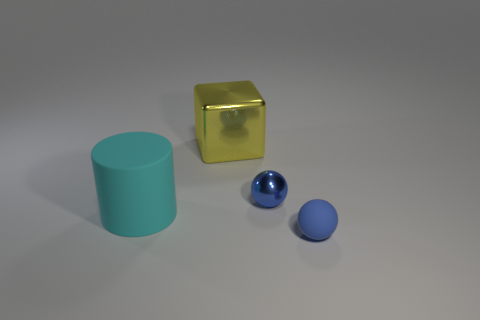What number of things are made of the same material as the big cyan cylinder?
Ensure brevity in your answer.  1. Do the tiny blue ball that is in front of the metallic sphere and the large yellow thing have the same material?
Give a very brief answer. No. Is the number of big rubber objects on the right side of the yellow metal block the same as the number of purple metal balls?
Offer a terse response. Yes. What is the size of the cylinder?
Keep it short and to the point. Large. What material is the object that is the same color as the metal ball?
Make the answer very short. Rubber. How many large metal blocks are the same color as the matte cylinder?
Keep it short and to the point. 0. Do the blue metallic sphere and the rubber sphere have the same size?
Provide a succinct answer. Yes. What is the size of the object right of the blue sphere to the left of the tiny rubber ball?
Provide a short and direct response. Small. There is a small rubber ball; does it have the same color as the small thing that is on the left side of the tiny blue matte thing?
Ensure brevity in your answer.  Yes. Are there any yellow metallic things that have the same size as the matte ball?
Offer a terse response. No. 